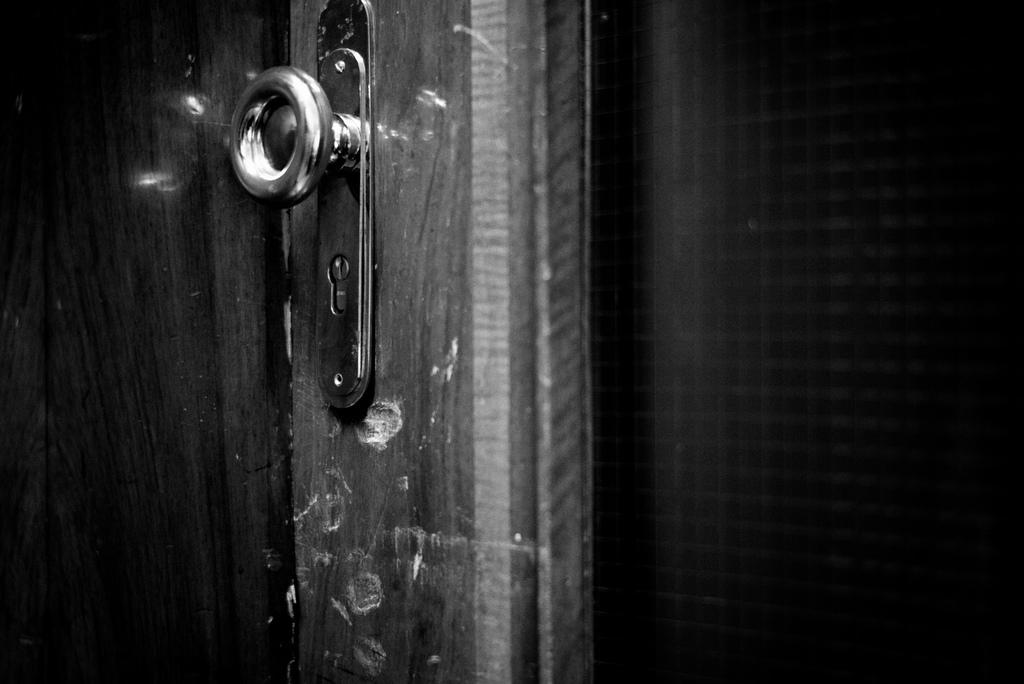What is the color scheme of the image? The image is black and white. What can be seen in the image? There is a door in the image. Is there any specific feature on the door? Yes, there is a lock in the middle of the door. Can you see any bite marks on the door in the image? There are no bite marks visible on the door in the image. What type of lipstick is being used on the door in the image? There is no lipstick or any indication of lipstick use on the door in the image. 